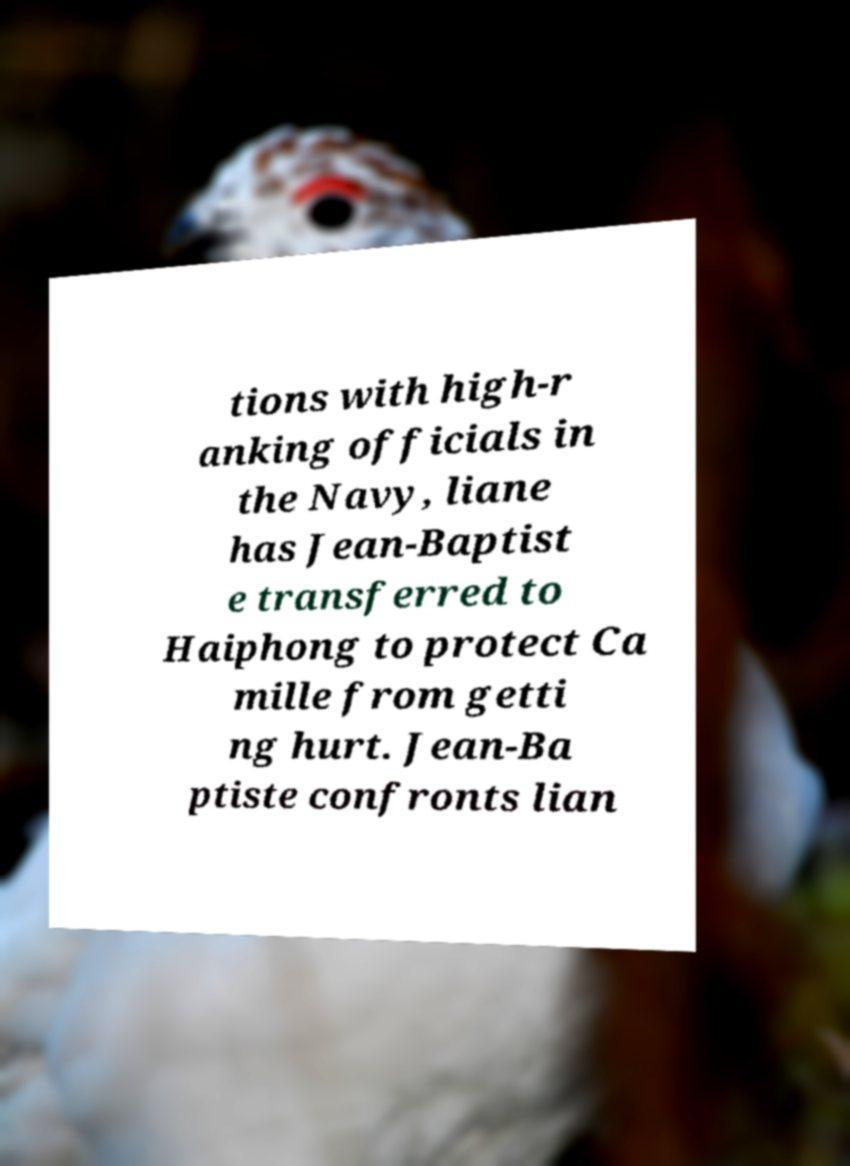Could you assist in decoding the text presented in this image and type it out clearly? tions with high-r anking officials in the Navy, liane has Jean-Baptist e transferred to Haiphong to protect Ca mille from getti ng hurt. Jean-Ba ptiste confronts lian 